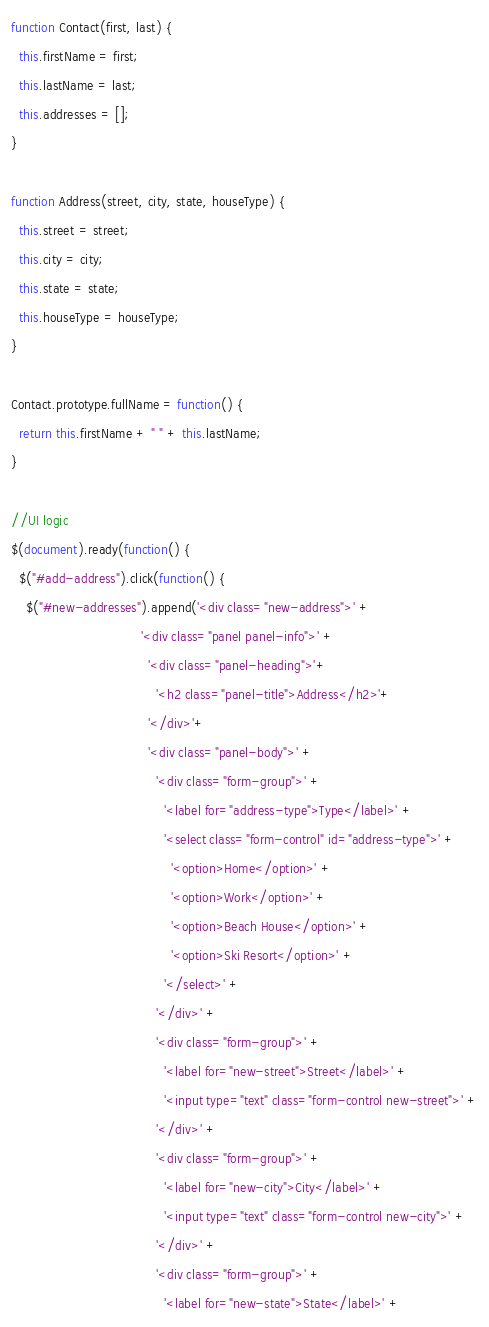Convert code to text. <code><loc_0><loc_0><loc_500><loc_500><_JavaScript_>function Contact(first, last) {
  this.firstName = first;
  this.lastName = last;
  this.addresses = [];
}

function Address(street, city, state, houseType) {
  this.street = street;
  this.city = city;
  this.state = state;
  this.houseType = houseType;
}

Contact.prototype.fullName = function() {
  return this.firstName + " " + this.lastName;
}

//UI logic
$(document).ready(function() {
  $("#add-address").click(function() {
    $("#new-addresses").append('<div class="new-address">' +
                                  '<div class="panel panel-info">' +
                                    '<div class="panel-heading">'+
                                      '<h2 class="panel-title">Address</h2>'+
                                    '</div>'+
                                    '<div class="panel-body">' +
                                      '<div class="form-group">' +
                                        '<label for="address-type">Type</label>' +
                                        '<select class="form-control" id="address-type">' +
                                          '<option>Home</option>' +
                                          '<option>Work</option>' +
                                          '<option>Beach House</option>' +
                                          '<option>Ski Resort</option>' +
                                        '</select>' +
                                      '</div>' +
                                      '<div class="form-group">' +
                                        '<label for="new-street">Street</label>' +
                                        '<input type="text" class="form-control new-street">' +
                                      '</div>' +
                                      '<div class="form-group">' +
                                        '<label for="new-city">City</label>' +
                                        '<input type="text" class="form-control new-city">' +
                                      '</div>' +
                                      '<div class="form-group">' +
                                        '<label for="new-state">State</label>' +</code> 